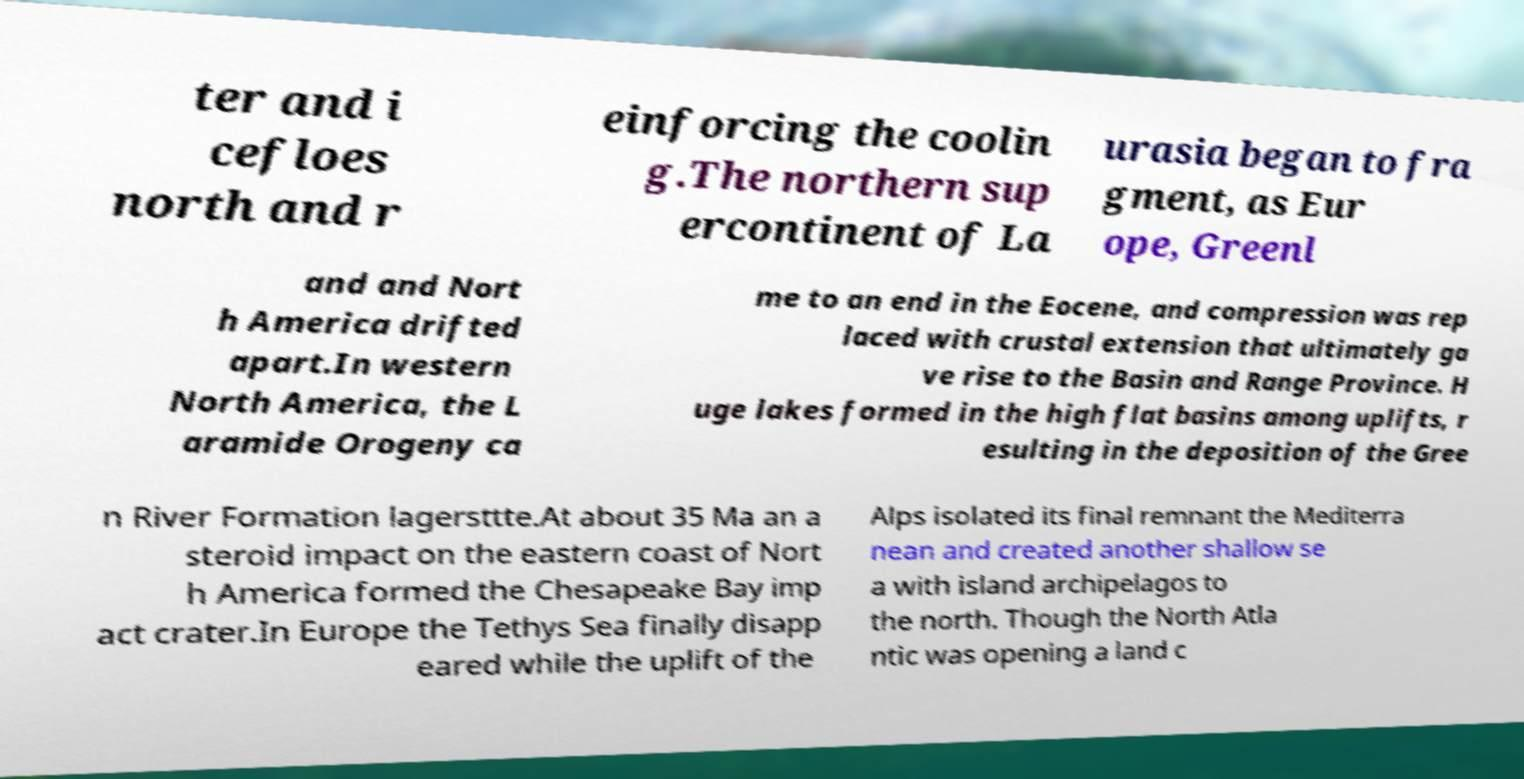Could you assist in decoding the text presented in this image and type it out clearly? ter and i cefloes north and r einforcing the coolin g.The northern sup ercontinent of La urasia began to fra gment, as Eur ope, Greenl and and Nort h America drifted apart.In western North America, the L aramide Orogeny ca me to an end in the Eocene, and compression was rep laced with crustal extension that ultimately ga ve rise to the Basin and Range Province. H uge lakes formed in the high flat basins among uplifts, r esulting in the deposition of the Gree n River Formation lagersttte.At about 35 Ma an a steroid impact on the eastern coast of Nort h America formed the Chesapeake Bay imp act crater.In Europe the Tethys Sea finally disapp eared while the uplift of the Alps isolated its final remnant the Mediterra nean and created another shallow se a with island archipelagos to the north. Though the North Atla ntic was opening a land c 